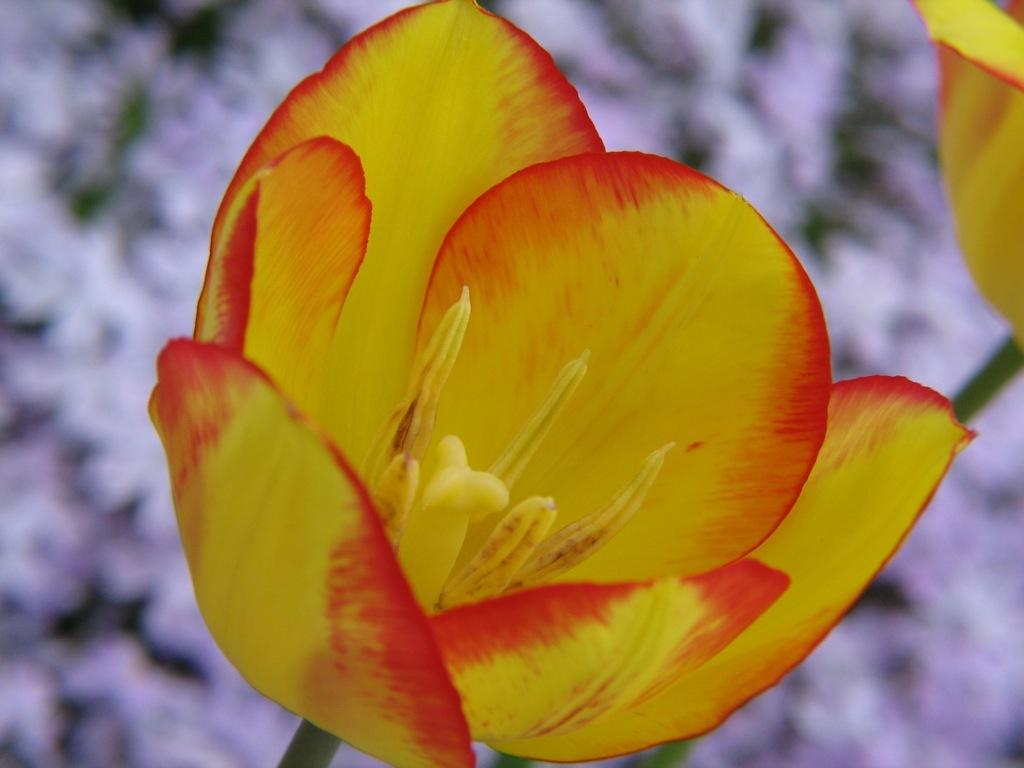What is the main subject of the image? There is a flower in the image. Can you describe any other flowers in the image? There is another flower in the background on the right side of the image. How would you describe the overall quality of the image? The image is blurry, but objects are still visible. What type of cream is being used as bait for the baseball game in the image? There is no cream, bait, or baseball game present in the image. 